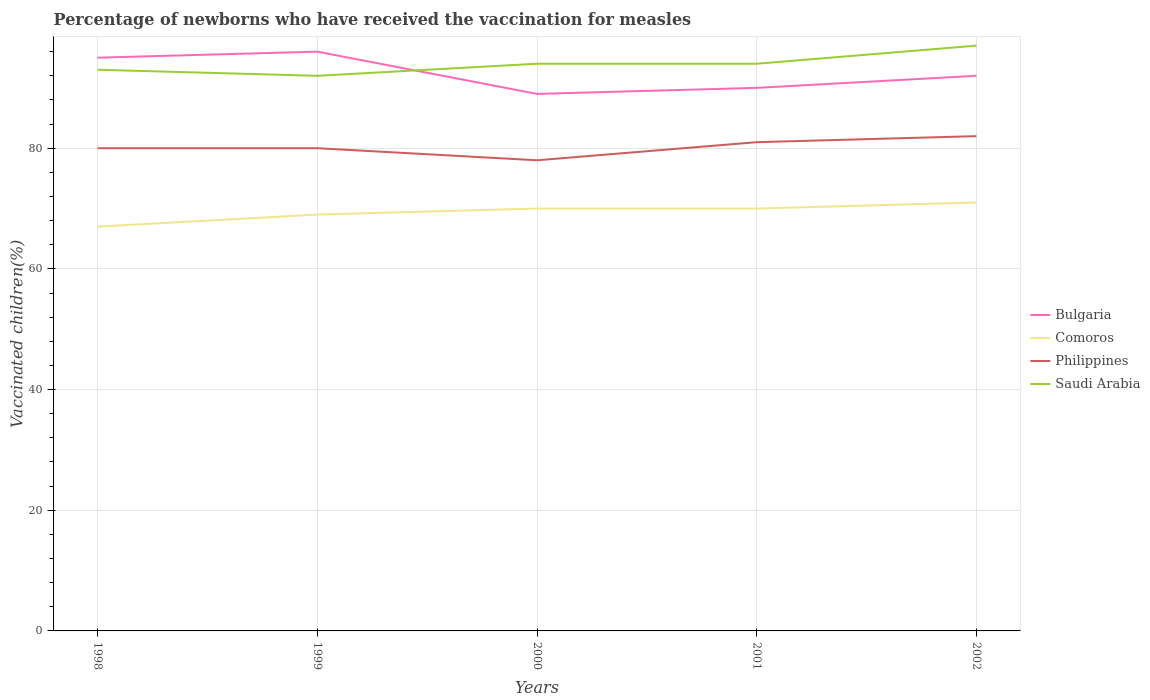Does the line corresponding to Comoros intersect with the line corresponding to Philippines?
Give a very brief answer. No. Across all years, what is the maximum percentage of vaccinated children in Comoros?
Offer a terse response. 67. In which year was the percentage of vaccinated children in Bulgaria maximum?
Keep it short and to the point. 2000. What is the total percentage of vaccinated children in Bulgaria in the graph?
Your answer should be compact. 3. What is the difference between the highest and the lowest percentage of vaccinated children in Bulgaria?
Ensure brevity in your answer.  2. How many lines are there?
Your answer should be very brief. 4. Does the graph contain grids?
Offer a very short reply. Yes. Where does the legend appear in the graph?
Your response must be concise. Center right. What is the title of the graph?
Provide a short and direct response. Percentage of newborns who have received the vaccination for measles. What is the label or title of the X-axis?
Your response must be concise. Years. What is the label or title of the Y-axis?
Ensure brevity in your answer.  Vaccinated children(%). What is the Vaccinated children(%) of Bulgaria in 1998?
Your response must be concise. 95. What is the Vaccinated children(%) of Saudi Arabia in 1998?
Give a very brief answer. 93. What is the Vaccinated children(%) of Bulgaria in 1999?
Your response must be concise. 96. What is the Vaccinated children(%) in Philippines in 1999?
Your answer should be very brief. 80. What is the Vaccinated children(%) in Saudi Arabia in 1999?
Offer a very short reply. 92. What is the Vaccinated children(%) in Bulgaria in 2000?
Provide a succinct answer. 89. What is the Vaccinated children(%) in Saudi Arabia in 2000?
Provide a short and direct response. 94. What is the Vaccinated children(%) in Bulgaria in 2001?
Offer a terse response. 90. What is the Vaccinated children(%) in Comoros in 2001?
Your response must be concise. 70. What is the Vaccinated children(%) of Saudi Arabia in 2001?
Provide a short and direct response. 94. What is the Vaccinated children(%) in Bulgaria in 2002?
Your response must be concise. 92. What is the Vaccinated children(%) of Comoros in 2002?
Make the answer very short. 71. What is the Vaccinated children(%) in Saudi Arabia in 2002?
Ensure brevity in your answer.  97. Across all years, what is the maximum Vaccinated children(%) in Bulgaria?
Ensure brevity in your answer.  96. Across all years, what is the maximum Vaccinated children(%) in Saudi Arabia?
Your answer should be very brief. 97. Across all years, what is the minimum Vaccinated children(%) of Bulgaria?
Your answer should be compact. 89. Across all years, what is the minimum Vaccinated children(%) in Philippines?
Your answer should be very brief. 78. Across all years, what is the minimum Vaccinated children(%) in Saudi Arabia?
Your response must be concise. 92. What is the total Vaccinated children(%) of Bulgaria in the graph?
Your answer should be compact. 462. What is the total Vaccinated children(%) in Comoros in the graph?
Your answer should be compact. 347. What is the total Vaccinated children(%) in Philippines in the graph?
Ensure brevity in your answer.  401. What is the total Vaccinated children(%) of Saudi Arabia in the graph?
Make the answer very short. 470. What is the difference between the Vaccinated children(%) of Comoros in 1998 and that in 1999?
Provide a short and direct response. -2. What is the difference between the Vaccinated children(%) in Philippines in 1998 and that in 1999?
Your answer should be very brief. 0. What is the difference between the Vaccinated children(%) in Comoros in 1998 and that in 2000?
Your answer should be compact. -3. What is the difference between the Vaccinated children(%) of Bulgaria in 1998 and that in 2001?
Ensure brevity in your answer.  5. What is the difference between the Vaccinated children(%) of Comoros in 1998 and that in 2001?
Provide a succinct answer. -3. What is the difference between the Vaccinated children(%) of Comoros in 1998 and that in 2002?
Your answer should be compact. -4. What is the difference between the Vaccinated children(%) of Philippines in 1998 and that in 2002?
Make the answer very short. -2. What is the difference between the Vaccinated children(%) in Saudi Arabia in 1998 and that in 2002?
Keep it short and to the point. -4. What is the difference between the Vaccinated children(%) of Bulgaria in 1999 and that in 2000?
Your answer should be very brief. 7. What is the difference between the Vaccinated children(%) of Philippines in 1999 and that in 2000?
Give a very brief answer. 2. What is the difference between the Vaccinated children(%) of Comoros in 1999 and that in 2001?
Give a very brief answer. -1. What is the difference between the Vaccinated children(%) of Saudi Arabia in 1999 and that in 2001?
Provide a succinct answer. -2. What is the difference between the Vaccinated children(%) in Philippines in 1999 and that in 2002?
Provide a succinct answer. -2. What is the difference between the Vaccinated children(%) in Saudi Arabia in 1999 and that in 2002?
Provide a succinct answer. -5. What is the difference between the Vaccinated children(%) in Comoros in 2000 and that in 2001?
Offer a terse response. 0. What is the difference between the Vaccinated children(%) in Saudi Arabia in 2000 and that in 2001?
Your answer should be compact. 0. What is the difference between the Vaccinated children(%) of Saudi Arabia in 2000 and that in 2002?
Your response must be concise. -3. What is the difference between the Vaccinated children(%) of Bulgaria in 2001 and that in 2002?
Keep it short and to the point. -2. What is the difference between the Vaccinated children(%) in Saudi Arabia in 2001 and that in 2002?
Your response must be concise. -3. What is the difference between the Vaccinated children(%) in Bulgaria in 1998 and the Vaccinated children(%) in Philippines in 1999?
Ensure brevity in your answer.  15. What is the difference between the Vaccinated children(%) in Bulgaria in 1998 and the Vaccinated children(%) in Saudi Arabia in 1999?
Give a very brief answer. 3. What is the difference between the Vaccinated children(%) of Comoros in 1998 and the Vaccinated children(%) of Philippines in 1999?
Your answer should be compact. -13. What is the difference between the Vaccinated children(%) of Comoros in 1998 and the Vaccinated children(%) of Saudi Arabia in 1999?
Provide a short and direct response. -25. What is the difference between the Vaccinated children(%) of Bulgaria in 1998 and the Vaccinated children(%) of Philippines in 2000?
Keep it short and to the point. 17. What is the difference between the Vaccinated children(%) in Bulgaria in 1998 and the Vaccinated children(%) in Saudi Arabia in 2000?
Ensure brevity in your answer.  1. What is the difference between the Vaccinated children(%) of Comoros in 1998 and the Vaccinated children(%) of Philippines in 2000?
Offer a very short reply. -11. What is the difference between the Vaccinated children(%) of Comoros in 1998 and the Vaccinated children(%) of Saudi Arabia in 2000?
Provide a short and direct response. -27. What is the difference between the Vaccinated children(%) in Bulgaria in 1998 and the Vaccinated children(%) in Saudi Arabia in 2001?
Provide a succinct answer. 1. What is the difference between the Vaccinated children(%) in Bulgaria in 1998 and the Vaccinated children(%) in Comoros in 2002?
Provide a short and direct response. 24. What is the difference between the Vaccinated children(%) of Bulgaria in 1998 and the Vaccinated children(%) of Saudi Arabia in 2002?
Ensure brevity in your answer.  -2. What is the difference between the Vaccinated children(%) of Comoros in 1998 and the Vaccinated children(%) of Philippines in 2002?
Offer a very short reply. -15. What is the difference between the Vaccinated children(%) of Comoros in 1998 and the Vaccinated children(%) of Saudi Arabia in 2002?
Provide a short and direct response. -30. What is the difference between the Vaccinated children(%) of Philippines in 1998 and the Vaccinated children(%) of Saudi Arabia in 2002?
Provide a succinct answer. -17. What is the difference between the Vaccinated children(%) of Comoros in 1999 and the Vaccinated children(%) of Philippines in 2000?
Your answer should be compact. -9. What is the difference between the Vaccinated children(%) in Philippines in 1999 and the Vaccinated children(%) in Saudi Arabia in 2000?
Offer a terse response. -14. What is the difference between the Vaccinated children(%) in Bulgaria in 1999 and the Vaccinated children(%) in Comoros in 2001?
Offer a terse response. 26. What is the difference between the Vaccinated children(%) in Bulgaria in 1999 and the Vaccinated children(%) in Philippines in 2001?
Your answer should be compact. 15. What is the difference between the Vaccinated children(%) of Comoros in 1999 and the Vaccinated children(%) of Saudi Arabia in 2001?
Offer a terse response. -25. What is the difference between the Vaccinated children(%) in Philippines in 1999 and the Vaccinated children(%) in Saudi Arabia in 2001?
Provide a succinct answer. -14. What is the difference between the Vaccinated children(%) of Bulgaria in 1999 and the Vaccinated children(%) of Comoros in 2002?
Your response must be concise. 25. What is the difference between the Vaccinated children(%) in Bulgaria in 1999 and the Vaccinated children(%) in Saudi Arabia in 2002?
Keep it short and to the point. -1. What is the difference between the Vaccinated children(%) in Philippines in 1999 and the Vaccinated children(%) in Saudi Arabia in 2002?
Provide a short and direct response. -17. What is the difference between the Vaccinated children(%) in Bulgaria in 2000 and the Vaccinated children(%) in Comoros in 2001?
Ensure brevity in your answer.  19. What is the difference between the Vaccinated children(%) of Bulgaria in 2000 and the Vaccinated children(%) of Philippines in 2001?
Keep it short and to the point. 8. What is the difference between the Vaccinated children(%) in Bulgaria in 2000 and the Vaccinated children(%) in Saudi Arabia in 2001?
Provide a succinct answer. -5. What is the difference between the Vaccinated children(%) in Comoros in 2000 and the Vaccinated children(%) in Philippines in 2001?
Your answer should be compact. -11. What is the difference between the Vaccinated children(%) in Bulgaria in 2000 and the Vaccinated children(%) in Comoros in 2002?
Your answer should be very brief. 18. What is the difference between the Vaccinated children(%) in Bulgaria in 2000 and the Vaccinated children(%) in Philippines in 2002?
Keep it short and to the point. 7. What is the difference between the Vaccinated children(%) in Bulgaria in 2000 and the Vaccinated children(%) in Saudi Arabia in 2002?
Provide a short and direct response. -8. What is the difference between the Vaccinated children(%) in Philippines in 2001 and the Vaccinated children(%) in Saudi Arabia in 2002?
Give a very brief answer. -16. What is the average Vaccinated children(%) of Bulgaria per year?
Your answer should be very brief. 92.4. What is the average Vaccinated children(%) in Comoros per year?
Offer a very short reply. 69.4. What is the average Vaccinated children(%) of Philippines per year?
Keep it short and to the point. 80.2. What is the average Vaccinated children(%) of Saudi Arabia per year?
Offer a very short reply. 94. In the year 1998, what is the difference between the Vaccinated children(%) in Bulgaria and Vaccinated children(%) in Philippines?
Provide a short and direct response. 15. In the year 1998, what is the difference between the Vaccinated children(%) of Comoros and Vaccinated children(%) of Philippines?
Make the answer very short. -13. In the year 1998, what is the difference between the Vaccinated children(%) in Comoros and Vaccinated children(%) in Saudi Arabia?
Offer a terse response. -26. In the year 1998, what is the difference between the Vaccinated children(%) in Philippines and Vaccinated children(%) in Saudi Arabia?
Ensure brevity in your answer.  -13. In the year 1999, what is the difference between the Vaccinated children(%) of Bulgaria and Vaccinated children(%) of Comoros?
Offer a very short reply. 27. In the year 1999, what is the difference between the Vaccinated children(%) in Bulgaria and Vaccinated children(%) in Philippines?
Give a very brief answer. 16. In the year 1999, what is the difference between the Vaccinated children(%) in Comoros and Vaccinated children(%) in Philippines?
Give a very brief answer. -11. In the year 1999, what is the difference between the Vaccinated children(%) of Comoros and Vaccinated children(%) of Saudi Arabia?
Your answer should be very brief. -23. In the year 1999, what is the difference between the Vaccinated children(%) in Philippines and Vaccinated children(%) in Saudi Arabia?
Your answer should be compact. -12. In the year 2000, what is the difference between the Vaccinated children(%) of Comoros and Vaccinated children(%) of Philippines?
Your answer should be very brief. -8. In the year 2001, what is the difference between the Vaccinated children(%) of Bulgaria and Vaccinated children(%) of Comoros?
Offer a very short reply. 20. In the year 2001, what is the difference between the Vaccinated children(%) of Bulgaria and Vaccinated children(%) of Philippines?
Offer a very short reply. 9. In the year 2001, what is the difference between the Vaccinated children(%) in Bulgaria and Vaccinated children(%) in Saudi Arabia?
Offer a very short reply. -4. In the year 2001, what is the difference between the Vaccinated children(%) in Comoros and Vaccinated children(%) in Saudi Arabia?
Your answer should be very brief. -24. In the year 2002, what is the difference between the Vaccinated children(%) of Bulgaria and Vaccinated children(%) of Comoros?
Provide a short and direct response. 21. In the year 2002, what is the difference between the Vaccinated children(%) in Bulgaria and Vaccinated children(%) in Philippines?
Provide a short and direct response. 10. In the year 2002, what is the difference between the Vaccinated children(%) of Comoros and Vaccinated children(%) of Philippines?
Your response must be concise. -11. In the year 2002, what is the difference between the Vaccinated children(%) of Comoros and Vaccinated children(%) of Saudi Arabia?
Give a very brief answer. -26. In the year 2002, what is the difference between the Vaccinated children(%) of Philippines and Vaccinated children(%) of Saudi Arabia?
Keep it short and to the point. -15. What is the ratio of the Vaccinated children(%) in Philippines in 1998 to that in 1999?
Make the answer very short. 1. What is the ratio of the Vaccinated children(%) in Saudi Arabia in 1998 to that in 1999?
Provide a succinct answer. 1.01. What is the ratio of the Vaccinated children(%) of Bulgaria in 1998 to that in 2000?
Offer a terse response. 1.07. What is the ratio of the Vaccinated children(%) of Comoros in 1998 to that in 2000?
Provide a short and direct response. 0.96. What is the ratio of the Vaccinated children(%) of Philippines in 1998 to that in 2000?
Your answer should be very brief. 1.03. What is the ratio of the Vaccinated children(%) in Bulgaria in 1998 to that in 2001?
Give a very brief answer. 1.06. What is the ratio of the Vaccinated children(%) in Comoros in 1998 to that in 2001?
Your answer should be compact. 0.96. What is the ratio of the Vaccinated children(%) of Philippines in 1998 to that in 2001?
Provide a short and direct response. 0.99. What is the ratio of the Vaccinated children(%) in Saudi Arabia in 1998 to that in 2001?
Give a very brief answer. 0.99. What is the ratio of the Vaccinated children(%) of Bulgaria in 1998 to that in 2002?
Your answer should be compact. 1.03. What is the ratio of the Vaccinated children(%) of Comoros in 1998 to that in 2002?
Your answer should be very brief. 0.94. What is the ratio of the Vaccinated children(%) of Philippines in 1998 to that in 2002?
Provide a short and direct response. 0.98. What is the ratio of the Vaccinated children(%) of Saudi Arabia in 1998 to that in 2002?
Provide a succinct answer. 0.96. What is the ratio of the Vaccinated children(%) in Bulgaria in 1999 to that in 2000?
Your answer should be very brief. 1.08. What is the ratio of the Vaccinated children(%) of Comoros in 1999 to that in 2000?
Your answer should be compact. 0.99. What is the ratio of the Vaccinated children(%) in Philippines in 1999 to that in 2000?
Your response must be concise. 1.03. What is the ratio of the Vaccinated children(%) of Saudi Arabia in 1999 to that in 2000?
Ensure brevity in your answer.  0.98. What is the ratio of the Vaccinated children(%) in Bulgaria in 1999 to that in 2001?
Offer a terse response. 1.07. What is the ratio of the Vaccinated children(%) in Comoros in 1999 to that in 2001?
Provide a succinct answer. 0.99. What is the ratio of the Vaccinated children(%) of Saudi Arabia in 1999 to that in 2001?
Your answer should be compact. 0.98. What is the ratio of the Vaccinated children(%) of Bulgaria in 1999 to that in 2002?
Give a very brief answer. 1.04. What is the ratio of the Vaccinated children(%) in Comoros in 1999 to that in 2002?
Provide a succinct answer. 0.97. What is the ratio of the Vaccinated children(%) in Philippines in 1999 to that in 2002?
Offer a very short reply. 0.98. What is the ratio of the Vaccinated children(%) of Saudi Arabia in 1999 to that in 2002?
Offer a very short reply. 0.95. What is the ratio of the Vaccinated children(%) in Bulgaria in 2000 to that in 2001?
Offer a terse response. 0.99. What is the ratio of the Vaccinated children(%) of Comoros in 2000 to that in 2001?
Offer a very short reply. 1. What is the ratio of the Vaccinated children(%) of Saudi Arabia in 2000 to that in 2001?
Make the answer very short. 1. What is the ratio of the Vaccinated children(%) in Bulgaria in 2000 to that in 2002?
Provide a short and direct response. 0.97. What is the ratio of the Vaccinated children(%) of Comoros in 2000 to that in 2002?
Provide a succinct answer. 0.99. What is the ratio of the Vaccinated children(%) of Philippines in 2000 to that in 2002?
Provide a short and direct response. 0.95. What is the ratio of the Vaccinated children(%) of Saudi Arabia in 2000 to that in 2002?
Provide a succinct answer. 0.97. What is the ratio of the Vaccinated children(%) in Bulgaria in 2001 to that in 2002?
Keep it short and to the point. 0.98. What is the ratio of the Vaccinated children(%) of Comoros in 2001 to that in 2002?
Your response must be concise. 0.99. What is the ratio of the Vaccinated children(%) in Philippines in 2001 to that in 2002?
Offer a very short reply. 0.99. What is the ratio of the Vaccinated children(%) of Saudi Arabia in 2001 to that in 2002?
Provide a succinct answer. 0.97. What is the difference between the highest and the second highest Vaccinated children(%) of Philippines?
Offer a terse response. 1. What is the difference between the highest and the second highest Vaccinated children(%) in Saudi Arabia?
Your answer should be compact. 3. What is the difference between the highest and the lowest Vaccinated children(%) of Comoros?
Make the answer very short. 4. What is the difference between the highest and the lowest Vaccinated children(%) of Philippines?
Your response must be concise. 4. What is the difference between the highest and the lowest Vaccinated children(%) in Saudi Arabia?
Keep it short and to the point. 5. 